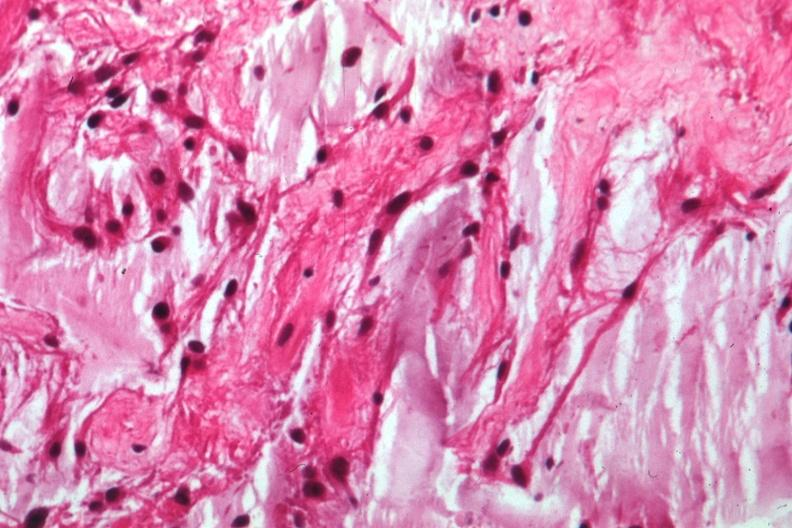s interesting case present?
Answer the question using a single word or phrase. No 